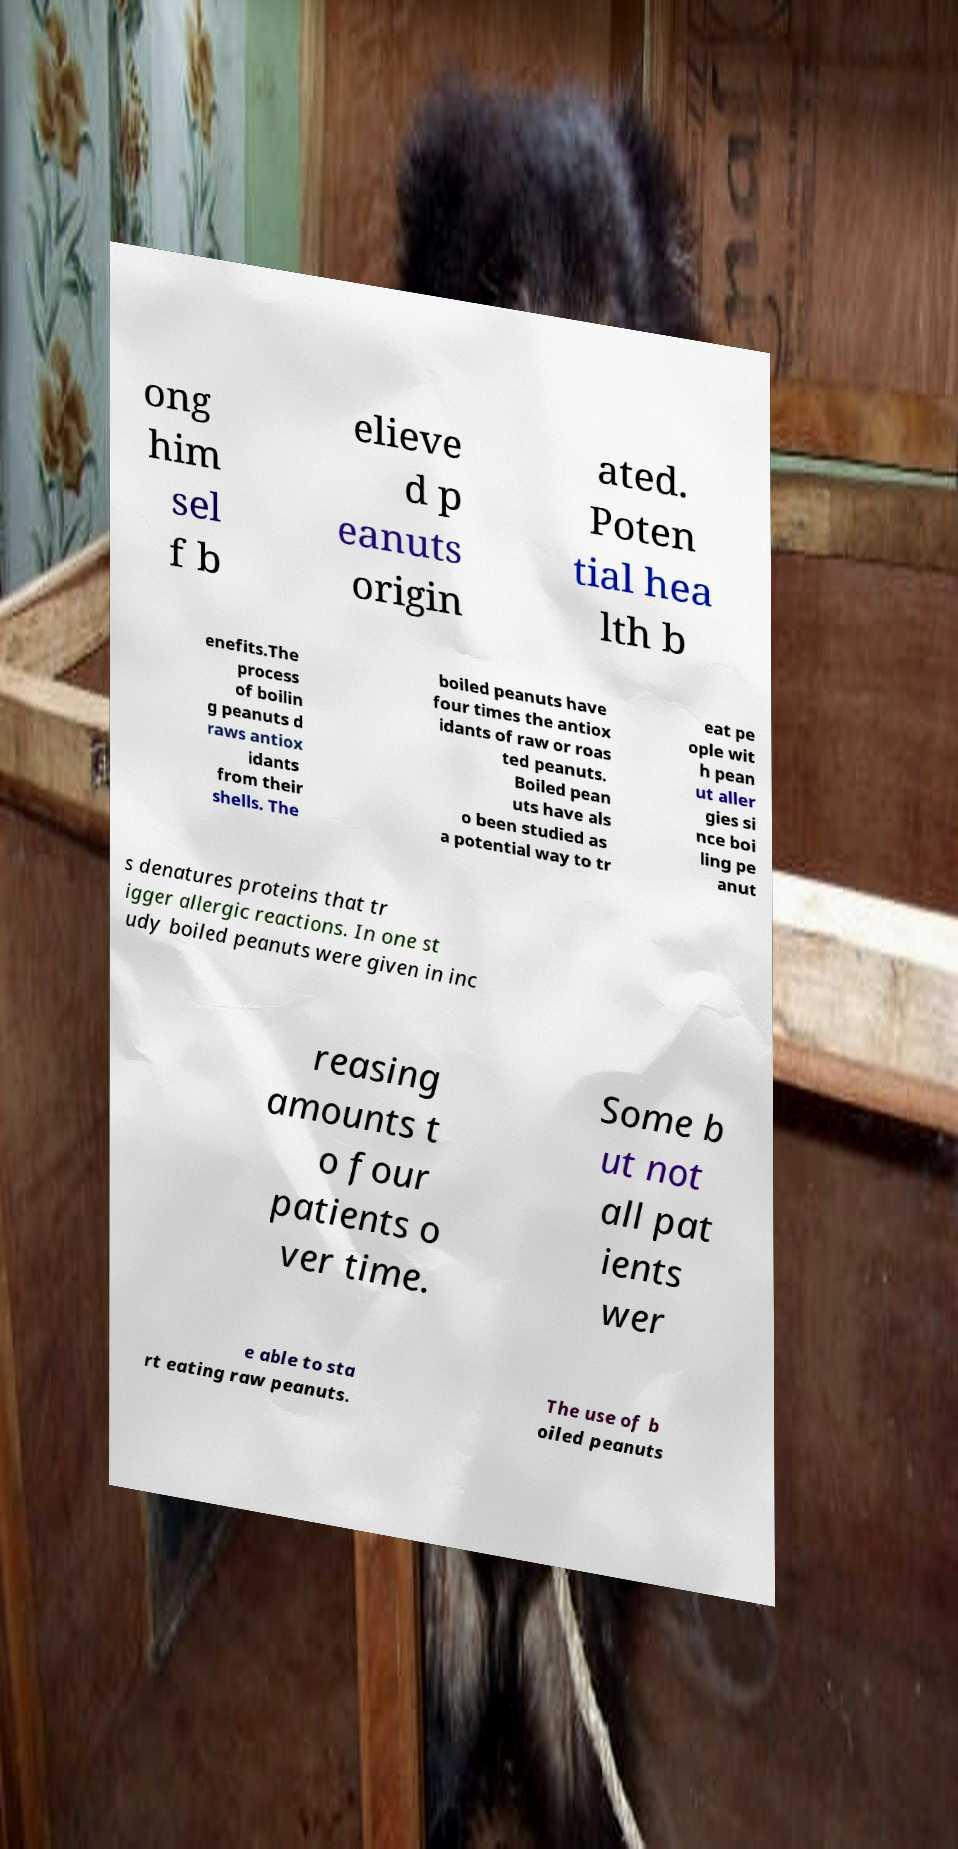Can you read and provide the text displayed in the image?This photo seems to have some interesting text. Can you extract and type it out for me? ong him sel f b elieve d p eanuts origin ated. Poten tial hea lth b enefits.The process of boilin g peanuts d raws antiox idants from their shells. The boiled peanuts have four times the antiox idants of raw or roas ted peanuts. Boiled pean uts have als o been studied as a potential way to tr eat pe ople wit h pean ut aller gies si nce boi ling pe anut s denatures proteins that tr igger allergic reactions. In one st udy boiled peanuts were given in inc reasing amounts t o four patients o ver time. Some b ut not all pat ients wer e able to sta rt eating raw peanuts. The use of b oiled peanuts 